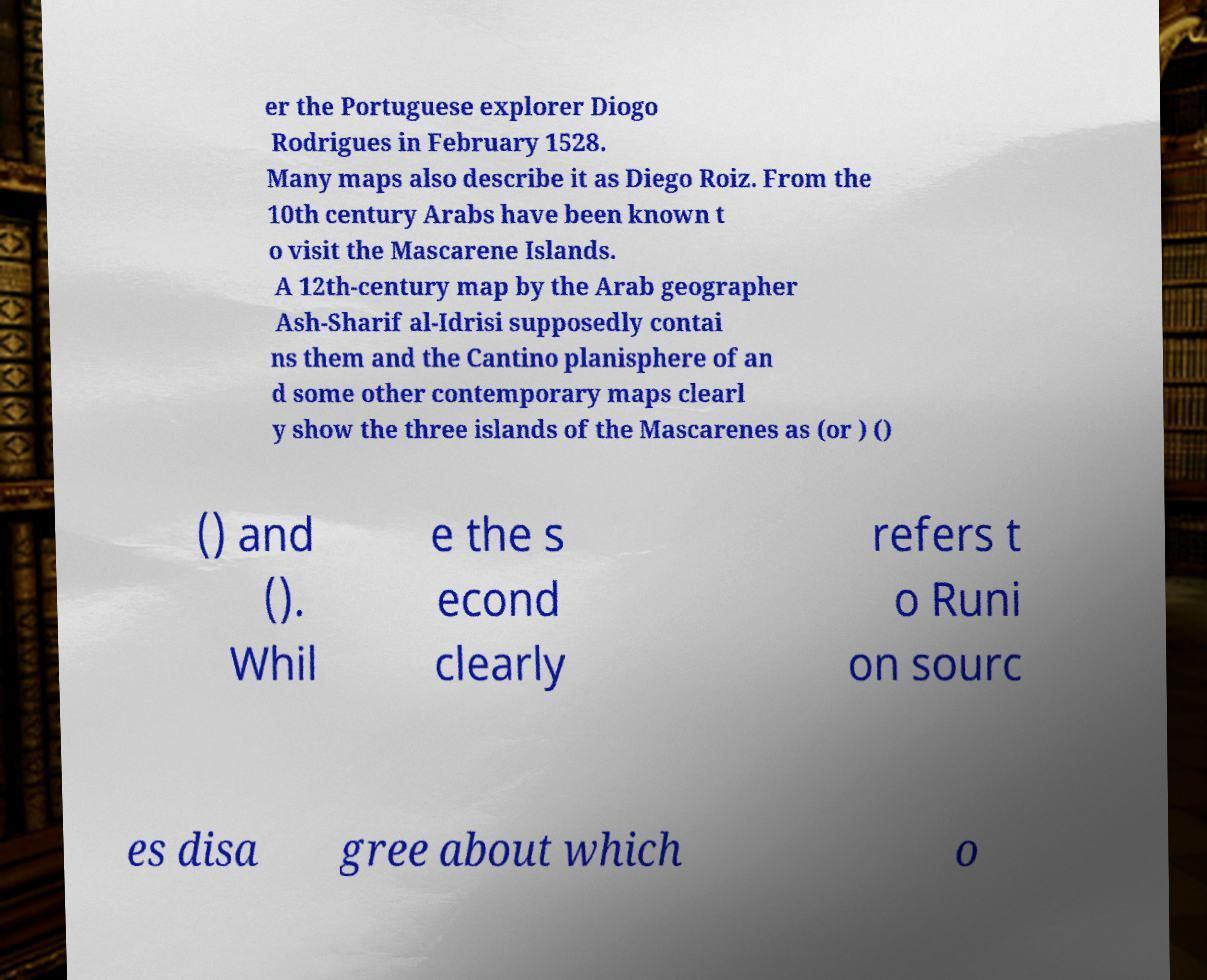Can you accurately transcribe the text from the provided image for me? er the Portuguese explorer Diogo Rodrigues in February 1528. Many maps also describe it as Diego Roiz. From the 10th century Arabs have been known t o visit the Mascarene Islands. A 12th-century map by the Arab geographer Ash-Sharif al-Idrisi supposedly contai ns them and the Cantino planisphere of an d some other contemporary maps clearl y show the three islands of the Mascarenes as (or ) () () and (). Whil e the s econd clearly refers t o Runi on sourc es disa gree about which o 